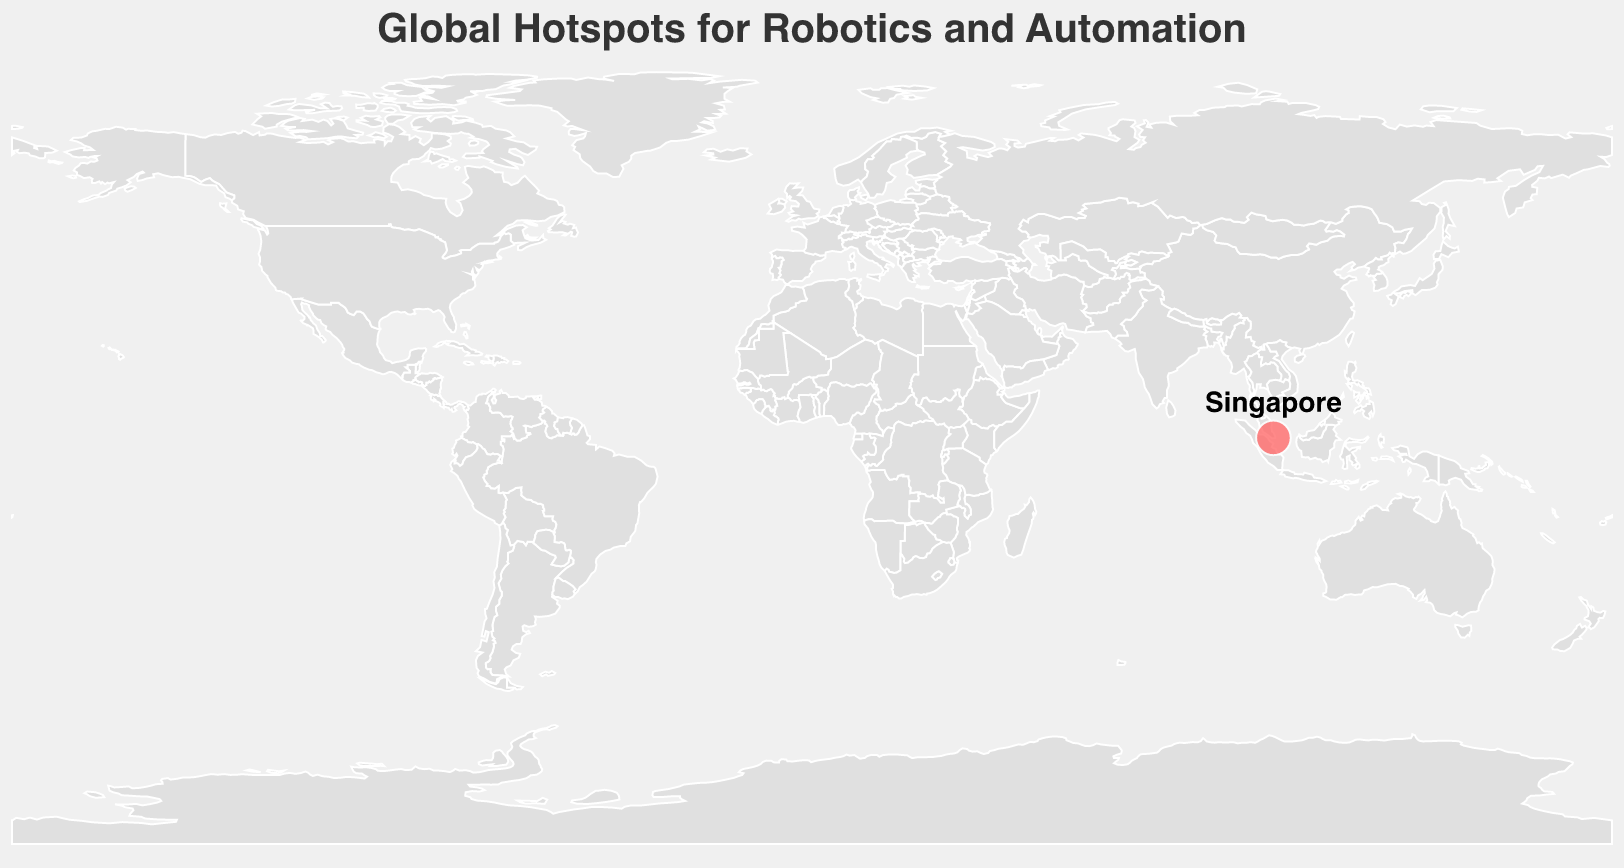What is the title of the figure? The title is usually placed at the top of the figure and it provides an overview of what the figure is about. The title for this figure is "Global Hotspots for Robotics and Automation".
Answer: Global Hotspots for Robotics and Automation Where is the specific location marked in the figure? The tooltip information and the text annotation indicate that there is a specific point marked on the map at the coordinates for Singapore.
Answer: Singapore What industry is associated with the robotics and automation hotspot in the figure? By looking at the tooltip or legend that appears when hovering over the marked point on the map, we can see that the industry is listed as Logistics.
Answer: Logistics What is the robotics score for the marked location in the figure? The robotics score is prominently displayed in the tooltip when hovering over the marked point. For Singapore, it is 85.
Answer: 85 What is a notable project mentioned for the marked location in the figure? The notable project can be found in the tooltip information that appears when hovering over the point. For Singapore, it is "Port of Singapore's Automated Container Handling System".
Answer: Port of Singapore's Automated Container Handling System Which location is shown to be a hotspot for logistics industry robotics and automation? The textual annotation and tooltip details indicate that the location marked in the figure for the logistics industry is Singapore.
Answer: Singapore How many data points are presented in the figure? The figure displays only one marked point on the map, indicating there is only one data entry for the robotics and automation hotspots.
Answer: 1 What visual elements are used to represent the hotspot in the figure? The hotspot in the figure is represented by a red circle which is semi-transparent and has a white border. There is also text annotation directly above the circle.
Answer: Red circle with white border and text annotation Compare the 'Robotics Score' of Singapore to another hypothetical city's score of 75. Which score is higher? Singapore's score of 85 is compared to the hypothetical score of 75. By direct numerical comparison, 85 is greater than 75.
Answer: Singapore's score is higher 